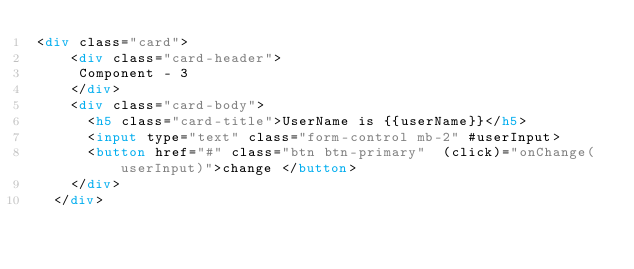Convert code to text. <code><loc_0><loc_0><loc_500><loc_500><_HTML_><div class="card">
    <div class="card-header">
     Component - 3
    </div>
    <div class="card-body">
      <h5 class="card-title">UserName is {{userName}}</h5>
      <input type="text" class="form-control mb-2" #userInput>
      <button href="#" class="btn btn-primary"  (click)="onChange(userInput)">change </button>
    </div>
  </div>
</code> 